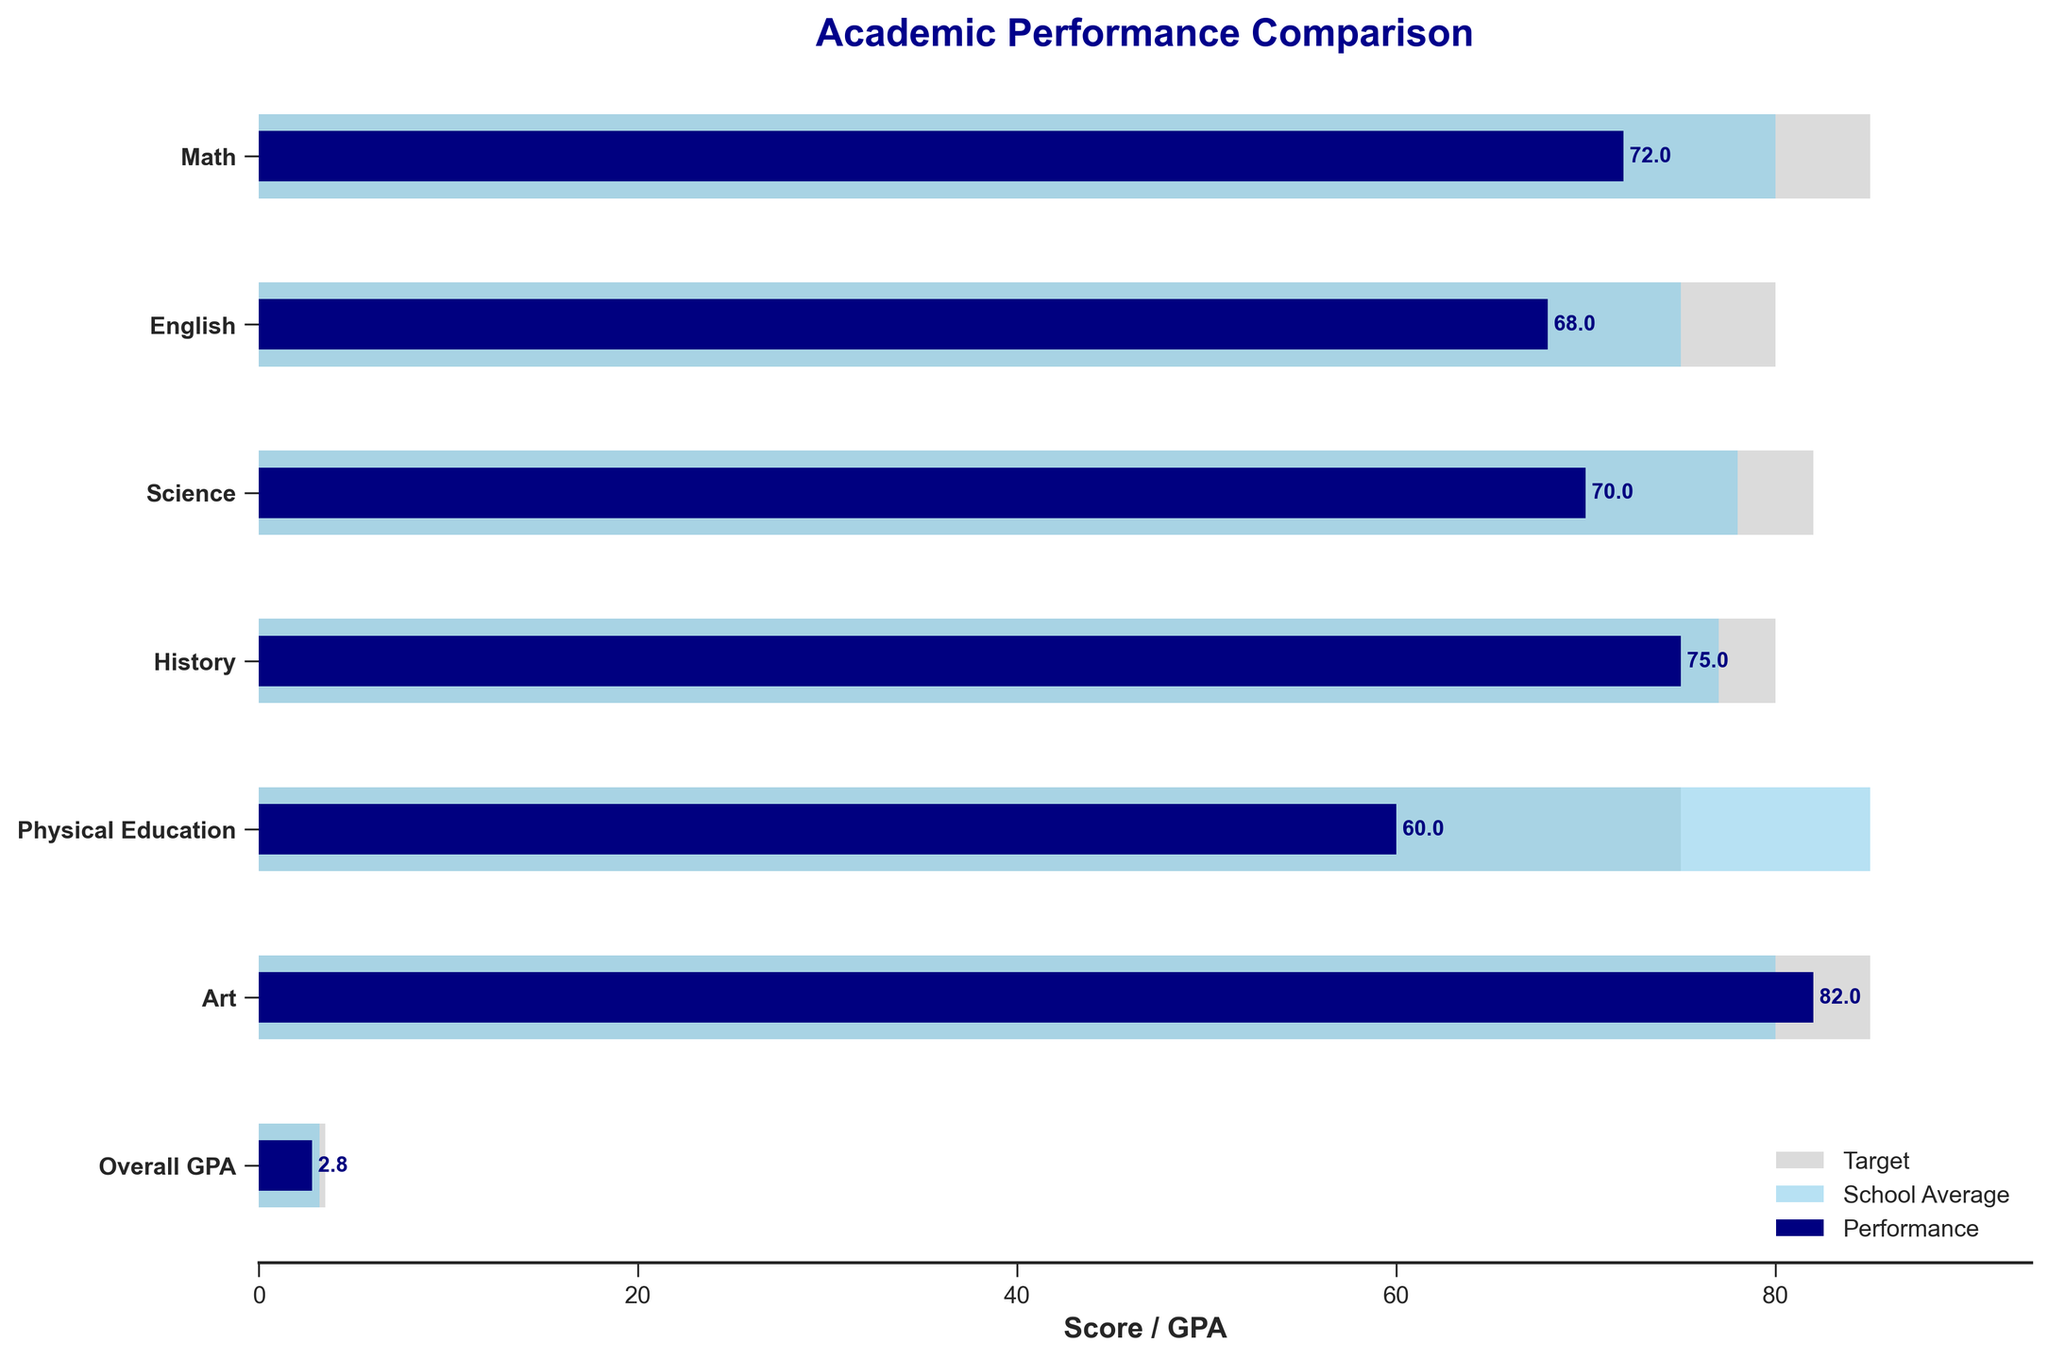What's the title of the chart? The title of the chart is typically at the top and it summarizes what the chart is about. Here it shows "Academic Performance Comparison".
Answer: Academic Performance Comparison What is the performance score in Math? The performance score in a subject is shown by the dark blue bar. For Math, this bar is located at the top. The text next to the bar indicates the score, which is 72.
Answer: 72 How does the performance in Physical Education compare to the school average? To compare, look at the two differently shaded bars for Physical Education. The performance bar (dark blue) is at 60, and the school average bar (sky blue) is at 85. So, the performance score is lower than the school average.
Answer: Lower Which subject has the highest Target score? The target bars (light grey) indicate the goals. By comparing the lengths, it is clear that Art has the highest target score of 85, which is also noted in the dataset.
Answer: Art What is the overall GPA performance score? The overall GPA performance score is in the last row, represented by the dark blue bar. The text next to the bar shows the score as 2.8.
Answer: 2.8 In which subject does the student have a higher performance than the school average? To find this, compare the performance and school average bars for each subject. In Art, the performance score (82) is higher than the school average (80).
Answer: Art What's the difference between the target score and performance in Science? The target score in Science is 82 and the performance score is 70. The difference is calculated as 82 - 70.
Answer: 12 Compare the student's performance in English and History. Which one is better? For comparison, look at the performance bars for both subjects. The performance score in English is 68, and in History, it is 75. The performance in History is better.
Answer: History What is the combined average of the school average scores for Math and Science? The school average for Math is 80, and for Science, it is 78. The combined average is (80 + 78) / 2.
Answer: 79 